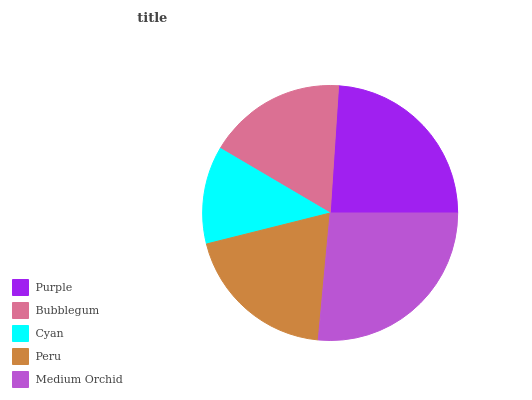Is Cyan the minimum?
Answer yes or no. Yes. Is Medium Orchid the maximum?
Answer yes or no. Yes. Is Bubblegum the minimum?
Answer yes or no. No. Is Bubblegum the maximum?
Answer yes or no. No. Is Purple greater than Bubblegum?
Answer yes or no. Yes. Is Bubblegum less than Purple?
Answer yes or no. Yes. Is Bubblegum greater than Purple?
Answer yes or no. No. Is Purple less than Bubblegum?
Answer yes or no. No. Is Peru the high median?
Answer yes or no. Yes. Is Peru the low median?
Answer yes or no. Yes. Is Purple the high median?
Answer yes or no. No. Is Cyan the low median?
Answer yes or no. No. 